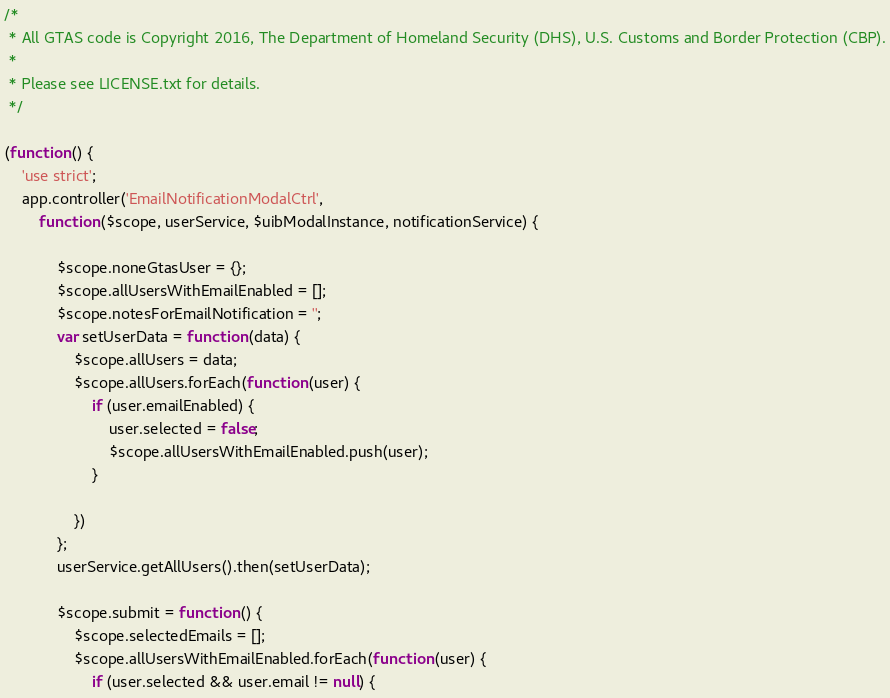Convert code to text. <code><loc_0><loc_0><loc_500><loc_500><_JavaScript_>/*
 * All GTAS code is Copyright 2016, The Department of Homeland Security (DHS), U.S. Customs and Border Protection (CBP).
 *
 * Please see LICENSE.txt for details.
 */

(function () {
    'use strict';
    app.controller('EmailNotificationModalCtrl',
        function ($scope, userService, $uibModalInstance, notificationService) {

            $scope.noneGtasUser = {};
            $scope.allUsersWithEmailEnabled = [];
            $scope.notesForEmailNotification = '';
            var setUserData = function (data) {
                $scope.allUsers = data;
                $scope.allUsers.forEach(function (user) {
                    if (user.emailEnabled) {
                        user.selected = false;
                        $scope.allUsersWithEmailEnabled.push(user);
                    }
                    
                })
            };
            userService.getAllUsers().then(setUserData);

            $scope.submit = function () {
                $scope.selectedEmails = [];
                $scope.allUsersWithEmailEnabled.forEach(function (user) {
                    if (user.selected && user.email != null) {</code> 